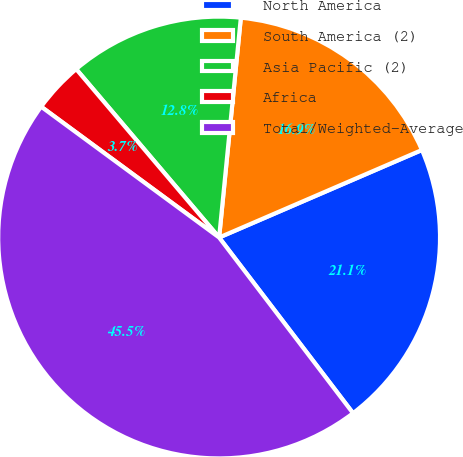Convert chart. <chart><loc_0><loc_0><loc_500><loc_500><pie_chart><fcel>North America<fcel>South America (2)<fcel>Asia Pacific (2)<fcel>Africa<fcel>Total/Weighted-Average<nl><fcel>21.12%<fcel>16.95%<fcel>12.77%<fcel>3.71%<fcel>45.46%<nl></chart> 